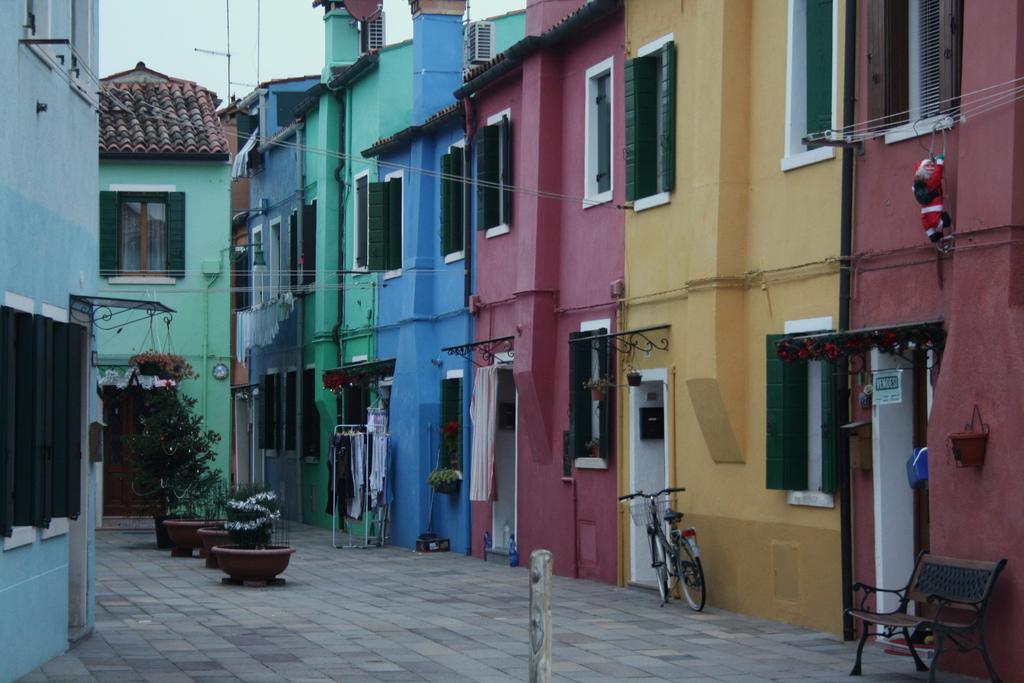Can you describe this image briefly? This picture is taken outside, there are group of buildings in different colors. There is a bench, a bicycle and a closet stand in in front of those buildings. In the left side there are some plants. In the top there is a blue sky. 